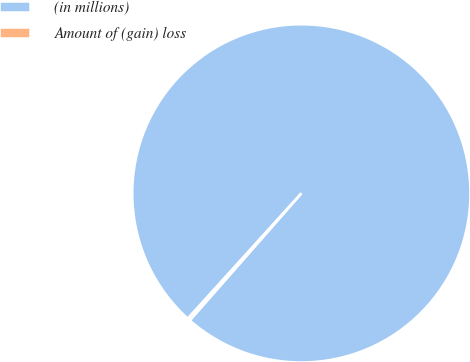Convert chart to OTSL. <chart><loc_0><loc_0><loc_500><loc_500><pie_chart><fcel>(in millions)<fcel>Amount of (gain) loss<nl><fcel>99.75%<fcel>0.25%<nl></chart> 